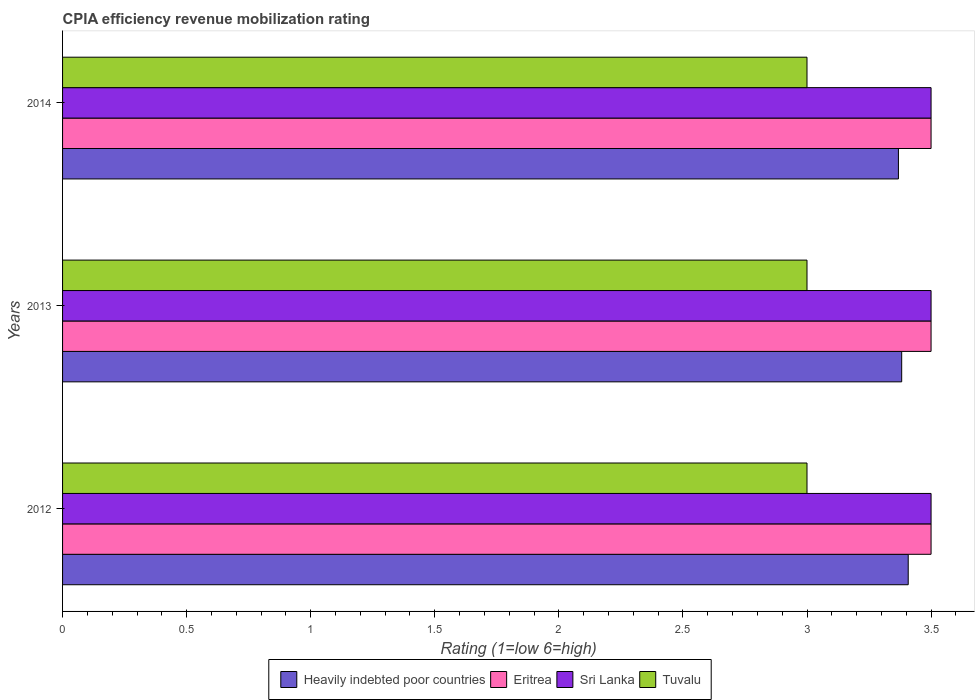How many different coloured bars are there?
Offer a terse response. 4. What is the label of the 1st group of bars from the top?
Ensure brevity in your answer.  2014. In how many cases, is the number of bars for a given year not equal to the number of legend labels?
Your response must be concise. 0. In which year was the CPIA rating in Sri Lanka maximum?
Your response must be concise. 2012. What is the total CPIA rating in Heavily indebted poor countries in the graph?
Make the answer very short. 10.16. What is the difference between the CPIA rating in Heavily indebted poor countries in 2013 and that in 2014?
Offer a terse response. 0.01. In the year 2012, what is the difference between the CPIA rating in Eritrea and CPIA rating in Heavily indebted poor countries?
Provide a succinct answer. 0.09. What is the difference between the highest and the lowest CPIA rating in Sri Lanka?
Give a very brief answer. 0. What does the 2nd bar from the top in 2013 represents?
Offer a terse response. Sri Lanka. What does the 2nd bar from the bottom in 2013 represents?
Keep it short and to the point. Eritrea. Are the values on the major ticks of X-axis written in scientific E-notation?
Make the answer very short. No. Does the graph contain any zero values?
Your answer should be compact. No. Does the graph contain grids?
Provide a short and direct response. No. How many legend labels are there?
Offer a very short reply. 4. How are the legend labels stacked?
Your answer should be compact. Horizontal. What is the title of the graph?
Make the answer very short. CPIA efficiency revenue mobilization rating. Does "North America" appear as one of the legend labels in the graph?
Provide a succinct answer. No. What is the label or title of the Y-axis?
Offer a very short reply. Years. What is the Rating (1=low 6=high) in Heavily indebted poor countries in 2012?
Offer a very short reply. 3.41. What is the Rating (1=low 6=high) in Eritrea in 2012?
Ensure brevity in your answer.  3.5. What is the Rating (1=low 6=high) in Sri Lanka in 2012?
Give a very brief answer. 3.5. What is the Rating (1=low 6=high) of Heavily indebted poor countries in 2013?
Offer a terse response. 3.38. What is the Rating (1=low 6=high) of Eritrea in 2013?
Your answer should be compact. 3.5. What is the Rating (1=low 6=high) in Sri Lanka in 2013?
Give a very brief answer. 3.5. What is the Rating (1=low 6=high) in Heavily indebted poor countries in 2014?
Make the answer very short. 3.37. What is the Rating (1=low 6=high) in Eritrea in 2014?
Your response must be concise. 3.5. What is the Rating (1=low 6=high) of Sri Lanka in 2014?
Give a very brief answer. 3.5. Across all years, what is the maximum Rating (1=low 6=high) in Heavily indebted poor countries?
Provide a succinct answer. 3.41. Across all years, what is the maximum Rating (1=low 6=high) in Eritrea?
Offer a terse response. 3.5. Across all years, what is the maximum Rating (1=low 6=high) of Sri Lanka?
Give a very brief answer. 3.5. Across all years, what is the minimum Rating (1=low 6=high) of Heavily indebted poor countries?
Your response must be concise. 3.37. What is the total Rating (1=low 6=high) in Heavily indebted poor countries in the graph?
Your response must be concise. 10.16. What is the total Rating (1=low 6=high) of Eritrea in the graph?
Your response must be concise. 10.5. What is the difference between the Rating (1=low 6=high) of Heavily indebted poor countries in 2012 and that in 2013?
Your answer should be very brief. 0.03. What is the difference between the Rating (1=low 6=high) in Heavily indebted poor countries in 2012 and that in 2014?
Offer a very short reply. 0.04. What is the difference between the Rating (1=low 6=high) of Eritrea in 2012 and that in 2014?
Your answer should be very brief. 0. What is the difference between the Rating (1=low 6=high) in Sri Lanka in 2012 and that in 2014?
Provide a short and direct response. 0. What is the difference between the Rating (1=low 6=high) of Tuvalu in 2012 and that in 2014?
Provide a succinct answer. 0. What is the difference between the Rating (1=low 6=high) in Heavily indebted poor countries in 2013 and that in 2014?
Keep it short and to the point. 0.01. What is the difference between the Rating (1=low 6=high) in Eritrea in 2013 and that in 2014?
Give a very brief answer. 0. What is the difference between the Rating (1=low 6=high) of Tuvalu in 2013 and that in 2014?
Keep it short and to the point. 0. What is the difference between the Rating (1=low 6=high) of Heavily indebted poor countries in 2012 and the Rating (1=low 6=high) of Eritrea in 2013?
Make the answer very short. -0.09. What is the difference between the Rating (1=low 6=high) in Heavily indebted poor countries in 2012 and the Rating (1=low 6=high) in Sri Lanka in 2013?
Offer a very short reply. -0.09. What is the difference between the Rating (1=low 6=high) of Heavily indebted poor countries in 2012 and the Rating (1=low 6=high) of Tuvalu in 2013?
Ensure brevity in your answer.  0.41. What is the difference between the Rating (1=low 6=high) in Eritrea in 2012 and the Rating (1=low 6=high) in Sri Lanka in 2013?
Your answer should be compact. 0. What is the difference between the Rating (1=low 6=high) in Eritrea in 2012 and the Rating (1=low 6=high) in Tuvalu in 2013?
Provide a succinct answer. 0.5. What is the difference between the Rating (1=low 6=high) of Heavily indebted poor countries in 2012 and the Rating (1=low 6=high) of Eritrea in 2014?
Make the answer very short. -0.09. What is the difference between the Rating (1=low 6=high) in Heavily indebted poor countries in 2012 and the Rating (1=low 6=high) in Sri Lanka in 2014?
Your answer should be very brief. -0.09. What is the difference between the Rating (1=low 6=high) in Heavily indebted poor countries in 2012 and the Rating (1=low 6=high) in Tuvalu in 2014?
Give a very brief answer. 0.41. What is the difference between the Rating (1=low 6=high) in Eritrea in 2012 and the Rating (1=low 6=high) in Sri Lanka in 2014?
Provide a short and direct response. 0. What is the difference between the Rating (1=low 6=high) of Sri Lanka in 2012 and the Rating (1=low 6=high) of Tuvalu in 2014?
Give a very brief answer. 0.5. What is the difference between the Rating (1=low 6=high) in Heavily indebted poor countries in 2013 and the Rating (1=low 6=high) in Eritrea in 2014?
Provide a short and direct response. -0.12. What is the difference between the Rating (1=low 6=high) of Heavily indebted poor countries in 2013 and the Rating (1=low 6=high) of Sri Lanka in 2014?
Your response must be concise. -0.12. What is the difference between the Rating (1=low 6=high) in Heavily indebted poor countries in 2013 and the Rating (1=low 6=high) in Tuvalu in 2014?
Offer a very short reply. 0.38. What is the difference between the Rating (1=low 6=high) of Sri Lanka in 2013 and the Rating (1=low 6=high) of Tuvalu in 2014?
Offer a terse response. 0.5. What is the average Rating (1=low 6=high) in Heavily indebted poor countries per year?
Provide a short and direct response. 3.39. What is the average Rating (1=low 6=high) of Eritrea per year?
Ensure brevity in your answer.  3.5. In the year 2012, what is the difference between the Rating (1=low 6=high) of Heavily indebted poor countries and Rating (1=low 6=high) of Eritrea?
Give a very brief answer. -0.09. In the year 2012, what is the difference between the Rating (1=low 6=high) in Heavily indebted poor countries and Rating (1=low 6=high) in Sri Lanka?
Your answer should be compact. -0.09. In the year 2012, what is the difference between the Rating (1=low 6=high) of Heavily indebted poor countries and Rating (1=low 6=high) of Tuvalu?
Your answer should be compact. 0.41. In the year 2012, what is the difference between the Rating (1=low 6=high) of Eritrea and Rating (1=low 6=high) of Sri Lanka?
Keep it short and to the point. 0. In the year 2012, what is the difference between the Rating (1=low 6=high) of Eritrea and Rating (1=low 6=high) of Tuvalu?
Give a very brief answer. 0.5. In the year 2012, what is the difference between the Rating (1=low 6=high) of Sri Lanka and Rating (1=low 6=high) of Tuvalu?
Provide a short and direct response. 0.5. In the year 2013, what is the difference between the Rating (1=low 6=high) in Heavily indebted poor countries and Rating (1=low 6=high) in Eritrea?
Your answer should be very brief. -0.12. In the year 2013, what is the difference between the Rating (1=low 6=high) of Heavily indebted poor countries and Rating (1=low 6=high) of Sri Lanka?
Make the answer very short. -0.12. In the year 2013, what is the difference between the Rating (1=low 6=high) in Heavily indebted poor countries and Rating (1=low 6=high) in Tuvalu?
Offer a very short reply. 0.38. In the year 2013, what is the difference between the Rating (1=low 6=high) in Eritrea and Rating (1=low 6=high) in Sri Lanka?
Ensure brevity in your answer.  0. In the year 2013, what is the difference between the Rating (1=low 6=high) of Eritrea and Rating (1=low 6=high) of Tuvalu?
Your response must be concise. 0.5. In the year 2014, what is the difference between the Rating (1=low 6=high) of Heavily indebted poor countries and Rating (1=low 6=high) of Eritrea?
Your answer should be very brief. -0.13. In the year 2014, what is the difference between the Rating (1=low 6=high) in Heavily indebted poor countries and Rating (1=low 6=high) in Sri Lanka?
Offer a terse response. -0.13. In the year 2014, what is the difference between the Rating (1=low 6=high) of Heavily indebted poor countries and Rating (1=low 6=high) of Tuvalu?
Provide a succinct answer. 0.37. In the year 2014, what is the difference between the Rating (1=low 6=high) of Eritrea and Rating (1=low 6=high) of Sri Lanka?
Provide a succinct answer. 0. In the year 2014, what is the difference between the Rating (1=low 6=high) in Sri Lanka and Rating (1=low 6=high) in Tuvalu?
Offer a very short reply. 0.5. What is the ratio of the Rating (1=low 6=high) of Eritrea in 2012 to that in 2013?
Provide a succinct answer. 1. What is the ratio of the Rating (1=low 6=high) in Sri Lanka in 2012 to that in 2013?
Offer a terse response. 1. What is the ratio of the Rating (1=low 6=high) in Heavily indebted poor countries in 2012 to that in 2014?
Ensure brevity in your answer.  1.01. What is the ratio of the Rating (1=low 6=high) of Eritrea in 2012 to that in 2014?
Make the answer very short. 1. What is the ratio of the Rating (1=low 6=high) in Eritrea in 2013 to that in 2014?
Give a very brief answer. 1. What is the ratio of the Rating (1=low 6=high) of Sri Lanka in 2013 to that in 2014?
Keep it short and to the point. 1. What is the difference between the highest and the second highest Rating (1=low 6=high) in Heavily indebted poor countries?
Your answer should be very brief. 0.03. What is the difference between the highest and the second highest Rating (1=low 6=high) in Eritrea?
Provide a short and direct response. 0. What is the difference between the highest and the second highest Rating (1=low 6=high) of Sri Lanka?
Your answer should be very brief. 0. What is the difference between the highest and the second highest Rating (1=low 6=high) in Tuvalu?
Your answer should be very brief. 0. What is the difference between the highest and the lowest Rating (1=low 6=high) in Heavily indebted poor countries?
Ensure brevity in your answer.  0.04. What is the difference between the highest and the lowest Rating (1=low 6=high) in Sri Lanka?
Your response must be concise. 0. What is the difference between the highest and the lowest Rating (1=low 6=high) of Tuvalu?
Provide a succinct answer. 0. 